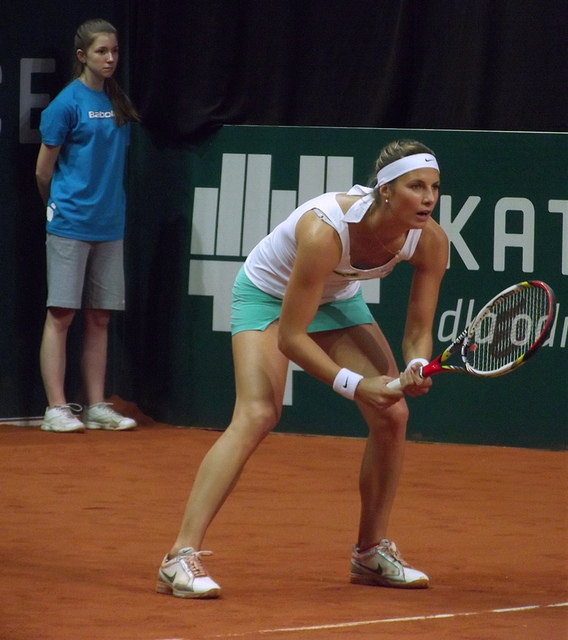<image>What brand is the racket? I am not sure what brand the racket is, but it could be Wilson. What is written on the wall? I don't know what is written on the wall. It could be 'kat', 'company logo', "sponsor's name", 'dla', 'katch'. What is the complete URL from the banner in the background? Sorry, the complete URL from the banner in the background is unclear. What brand is the racket? I don't know the brand of the racket. It can be Wilson. What is written on the wall? I am not sure what is written on the wall. It can be seen 'kat', 'company logo', "sponsor's name", 'dla', 'unknown', or 'katch'. What is the complete URL from the banner in the background? I don't know the complete URL from the banner in the background. It can be seen as 'kataorg', 'dlaord', 'katdlaorg', 'dlaad', 'dlaorg', or 'dlaod'. 